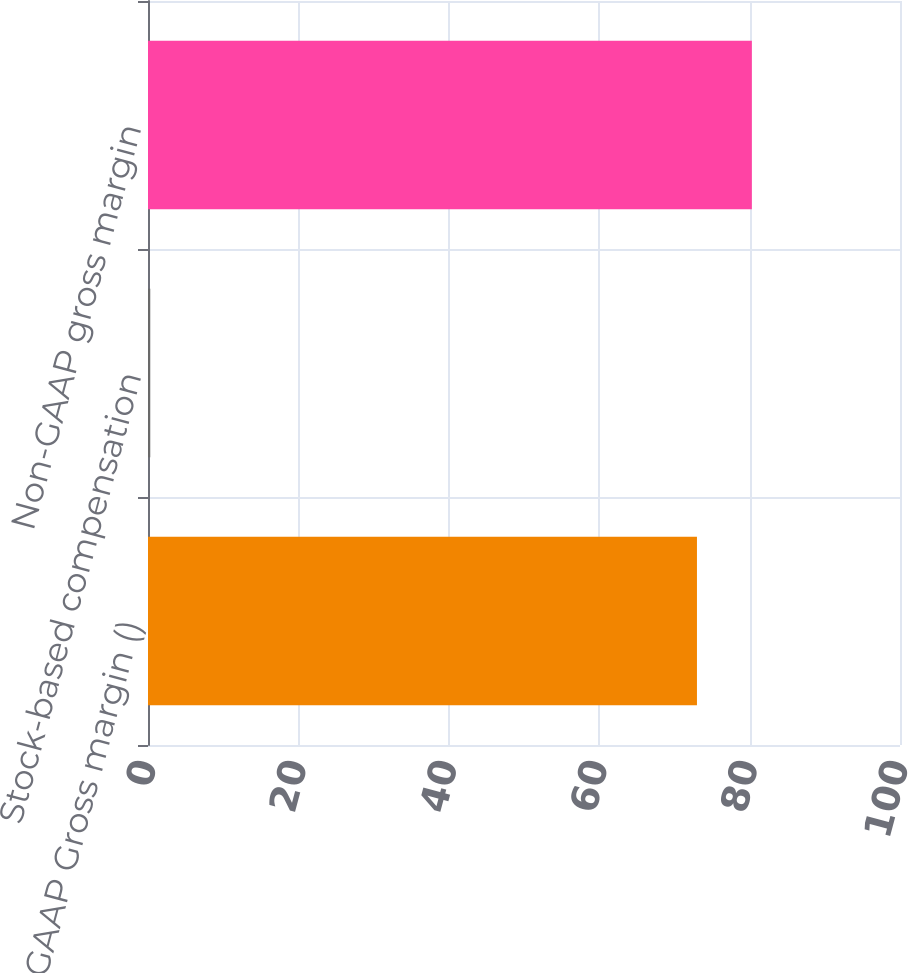<chart> <loc_0><loc_0><loc_500><loc_500><bar_chart><fcel>GAAP Gross margin ()<fcel>Stock-based compensation<fcel>Non-GAAP gross margin<nl><fcel>73<fcel>0.3<fcel>80.3<nl></chart> 